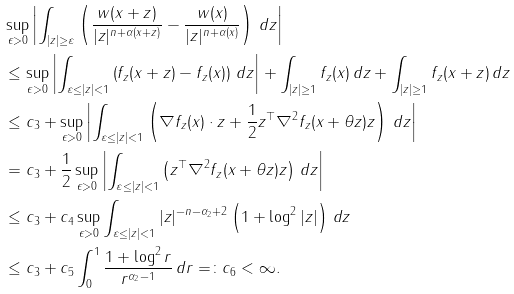Convert formula to latex. <formula><loc_0><loc_0><loc_500><loc_500>& \sup _ { \epsilon > 0 } \left | \int _ { | z | \geq \varepsilon } \left ( \frac { w ( x + z ) } { | z | ^ { n + \alpha ( x + z ) } } - \frac { w ( x ) } { | z | ^ { n + \alpha ( x ) } } \right ) \, d z \right | \\ & \leq \sup _ { \epsilon > 0 } \left | \int _ { \varepsilon \leq | z | < 1 } \left ( f _ { z } ( x + z ) - f _ { z } ( x ) \right ) \, d z \right | + \int _ { | z | \geq 1 } f _ { z } ( x ) \, d z + \int _ { | z | \geq 1 } f _ { z } ( x + z ) \, d z \\ & \leq c _ { 3 } + \sup _ { \epsilon > 0 } \left | \int _ { \varepsilon \leq | z | < 1 } \left ( \nabla f _ { z } ( x ) \cdot z + \frac { 1 } { 2 } z ^ { \top } \nabla ^ { 2 } f _ { z } ( x + \theta z ) z \right ) \, d z \right | \\ & = c _ { 3 } + \frac { 1 } { 2 } \sup _ { \epsilon > 0 } \left | \int _ { \varepsilon \leq | z | < 1 } \left ( z ^ { \top } \nabla ^ { 2 } f _ { z } ( x + \theta z ) z \right ) \, d z \right | \\ & \leq c _ { 3 } + c _ { 4 } \sup _ { \epsilon > 0 } \int _ { \varepsilon \leq | z | < 1 } | z | ^ { - n - \alpha _ { 2 } + 2 } \left ( 1 + \log ^ { 2 } | z | \right ) \, d z \\ & \leq c _ { 3 } + c _ { 5 } \int _ { 0 } ^ { 1 } \frac { 1 + \log ^ { 2 } r } { r ^ { \alpha _ { 2 } - 1 } } \, d r = \colon c _ { 6 } < \infty .</formula> 